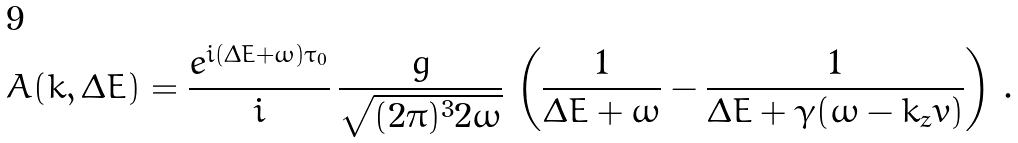<formula> <loc_0><loc_0><loc_500><loc_500>A ( k , \Delta E ) = \frac { e ^ { i ( \Delta E + \omega ) \tau _ { 0 } } } { i } \, \frac { \bar { g } } { \sqrt { ( 2 \pi ) ^ { 3 } 2 \omega } } \, \left ( \frac { 1 } { \Delta E + \omega } - \frac { 1 } { \Delta E + \gamma ( \omega - k _ { z } v ) } \right ) \, .</formula> 